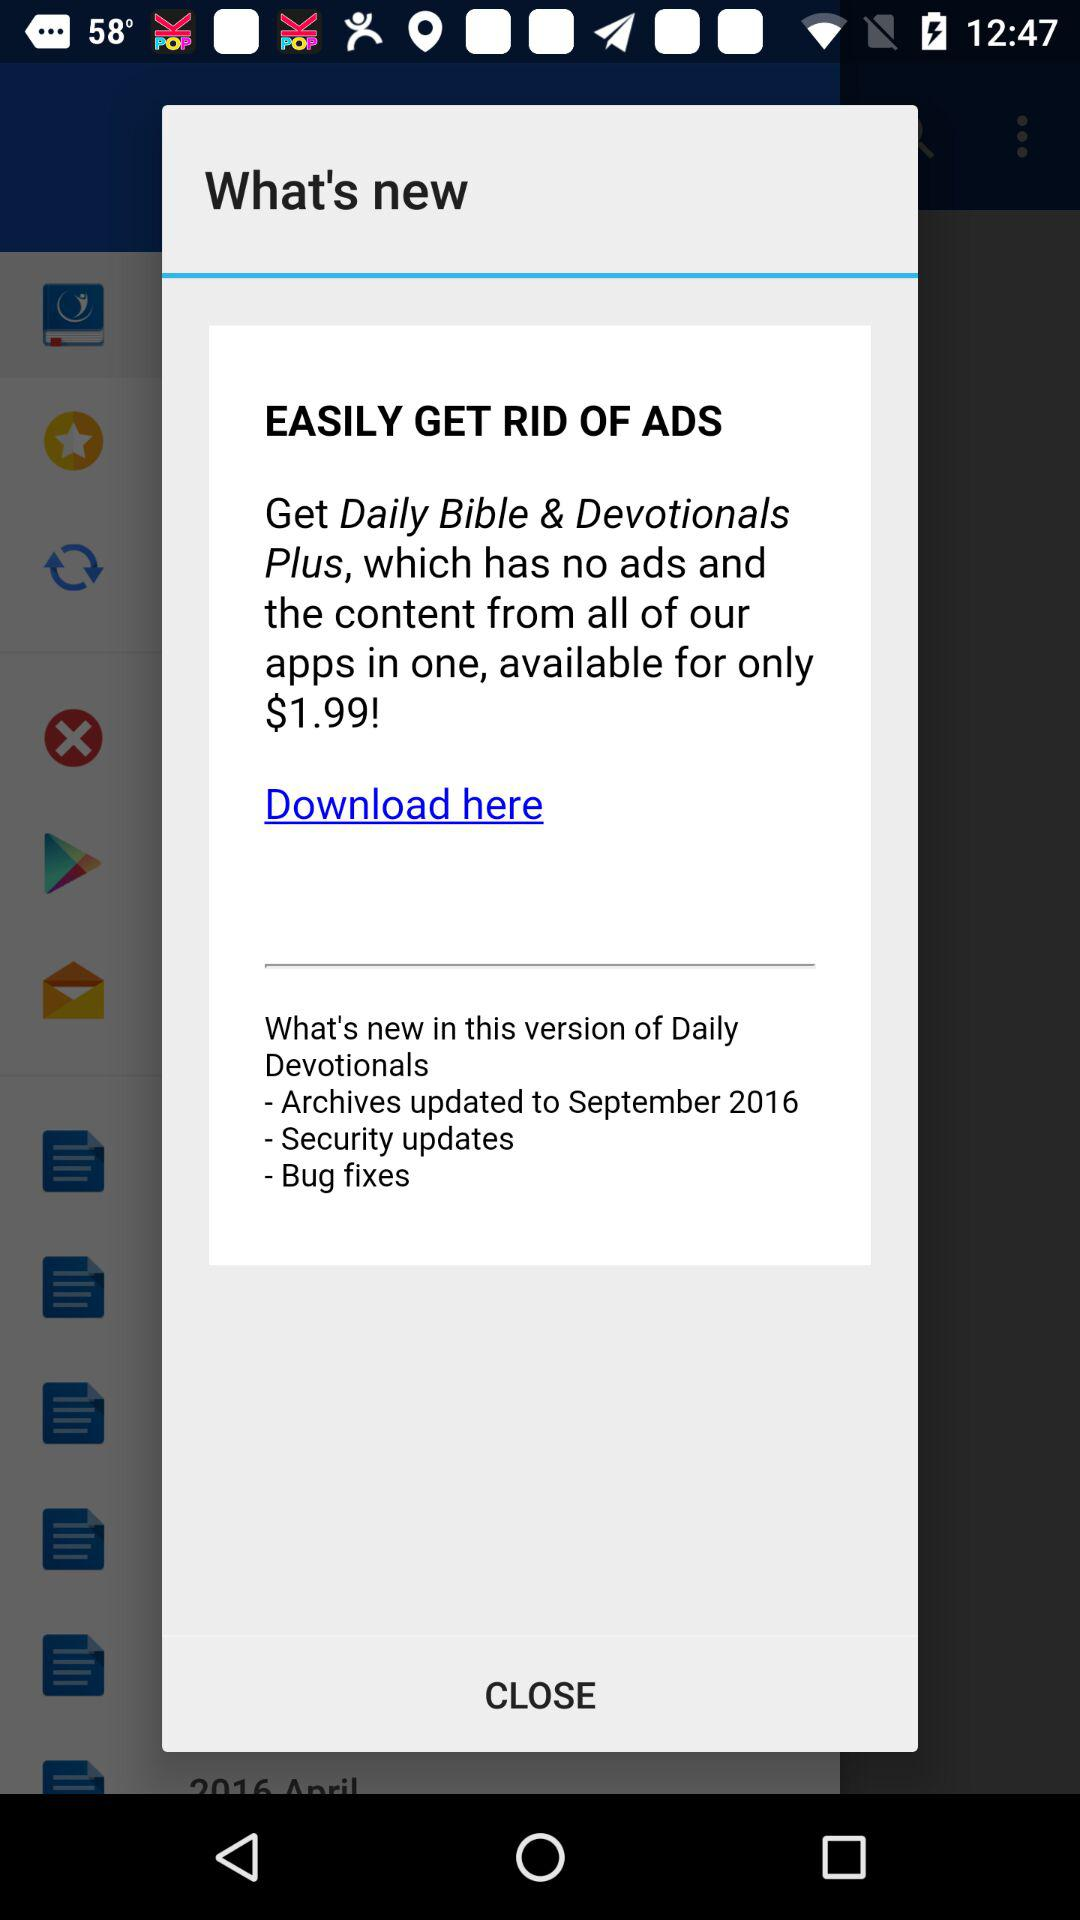What is the application name? The application name is "Daily Bible & Devotionals Plus". 